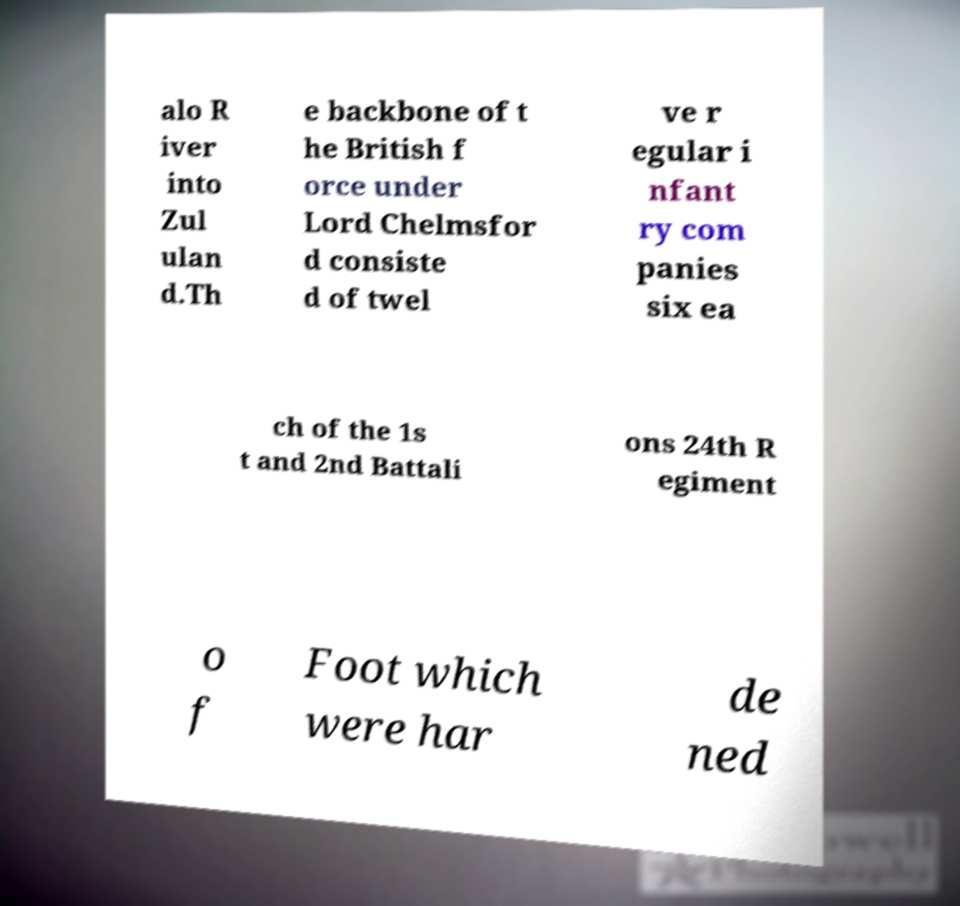There's text embedded in this image that I need extracted. Can you transcribe it verbatim? alo R iver into Zul ulan d.Th e backbone of t he British f orce under Lord Chelmsfor d consiste d of twel ve r egular i nfant ry com panies six ea ch of the 1s t and 2nd Battali ons 24th R egiment o f Foot which were har de ned 